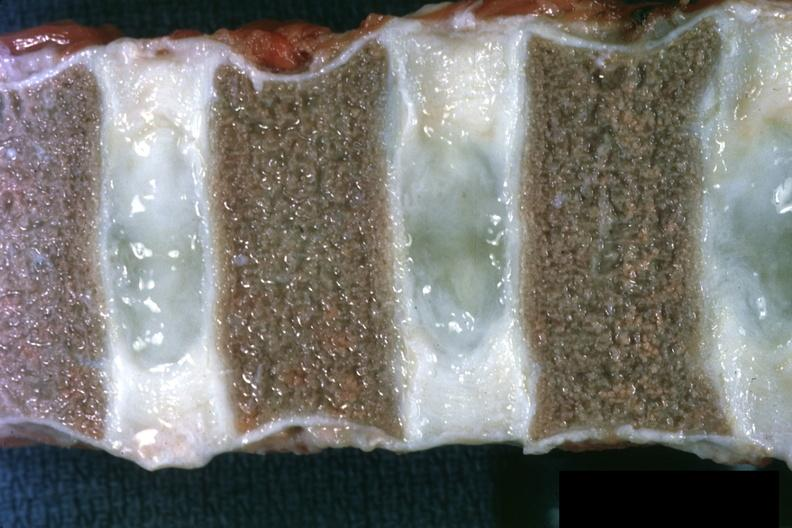how are not too spectacular discs well shown and?
Answer the question using a single word or phrase. Normal 